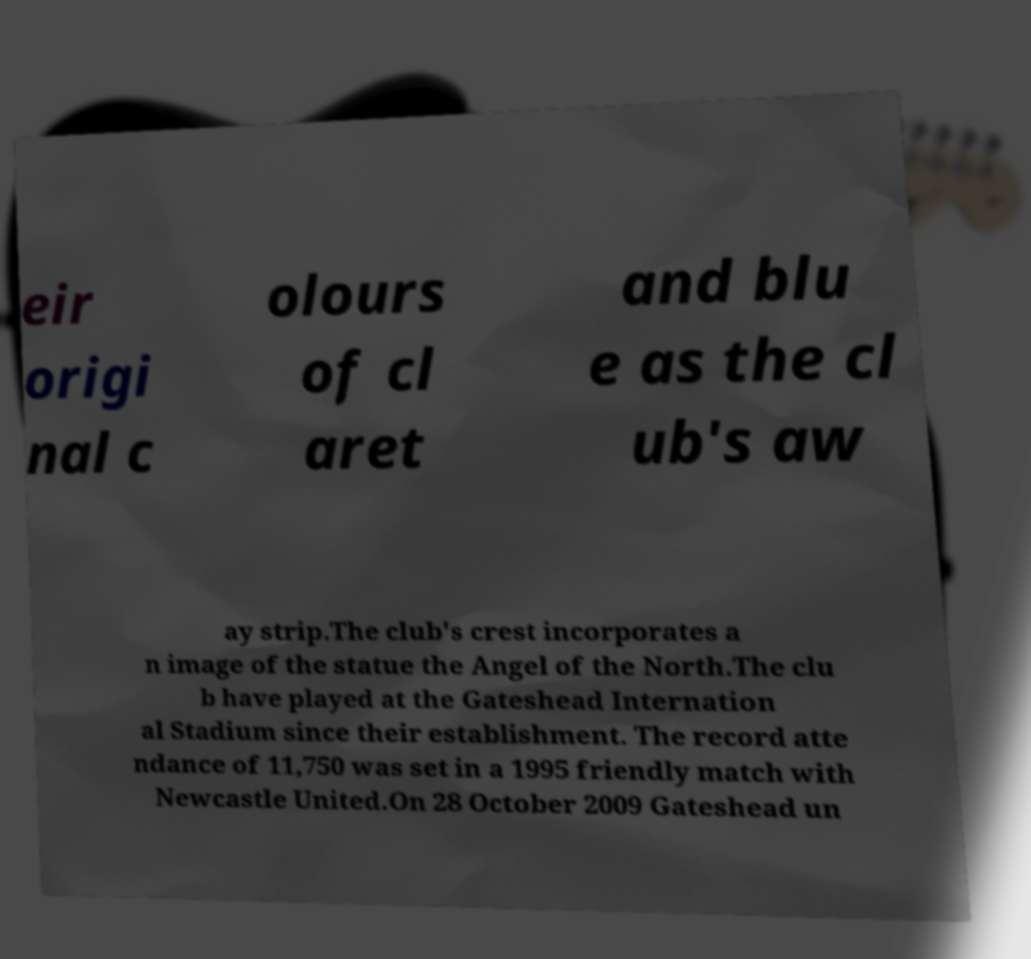Can you accurately transcribe the text from the provided image for me? eir origi nal c olours of cl aret and blu e as the cl ub's aw ay strip.The club's crest incorporates a n image of the statue the Angel of the North.The clu b have played at the Gateshead Internation al Stadium since their establishment. The record atte ndance of 11,750 was set in a 1995 friendly match with Newcastle United.On 28 October 2009 Gateshead un 